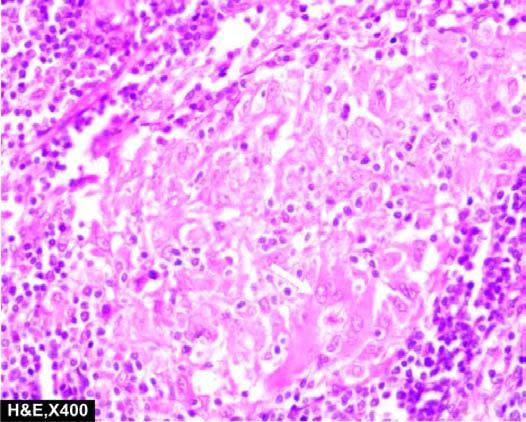s a giant cell with inclusions also seen in the photomicrograph?
Answer the question using a single word or phrase. Yes 